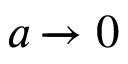Convert formula to latex. <formula><loc_0><loc_0><loc_500><loc_500>a \xrightarrow [ 0</formula> 